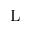<formula> <loc_0><loc_0><loc_500><loc_500>L</formula> 